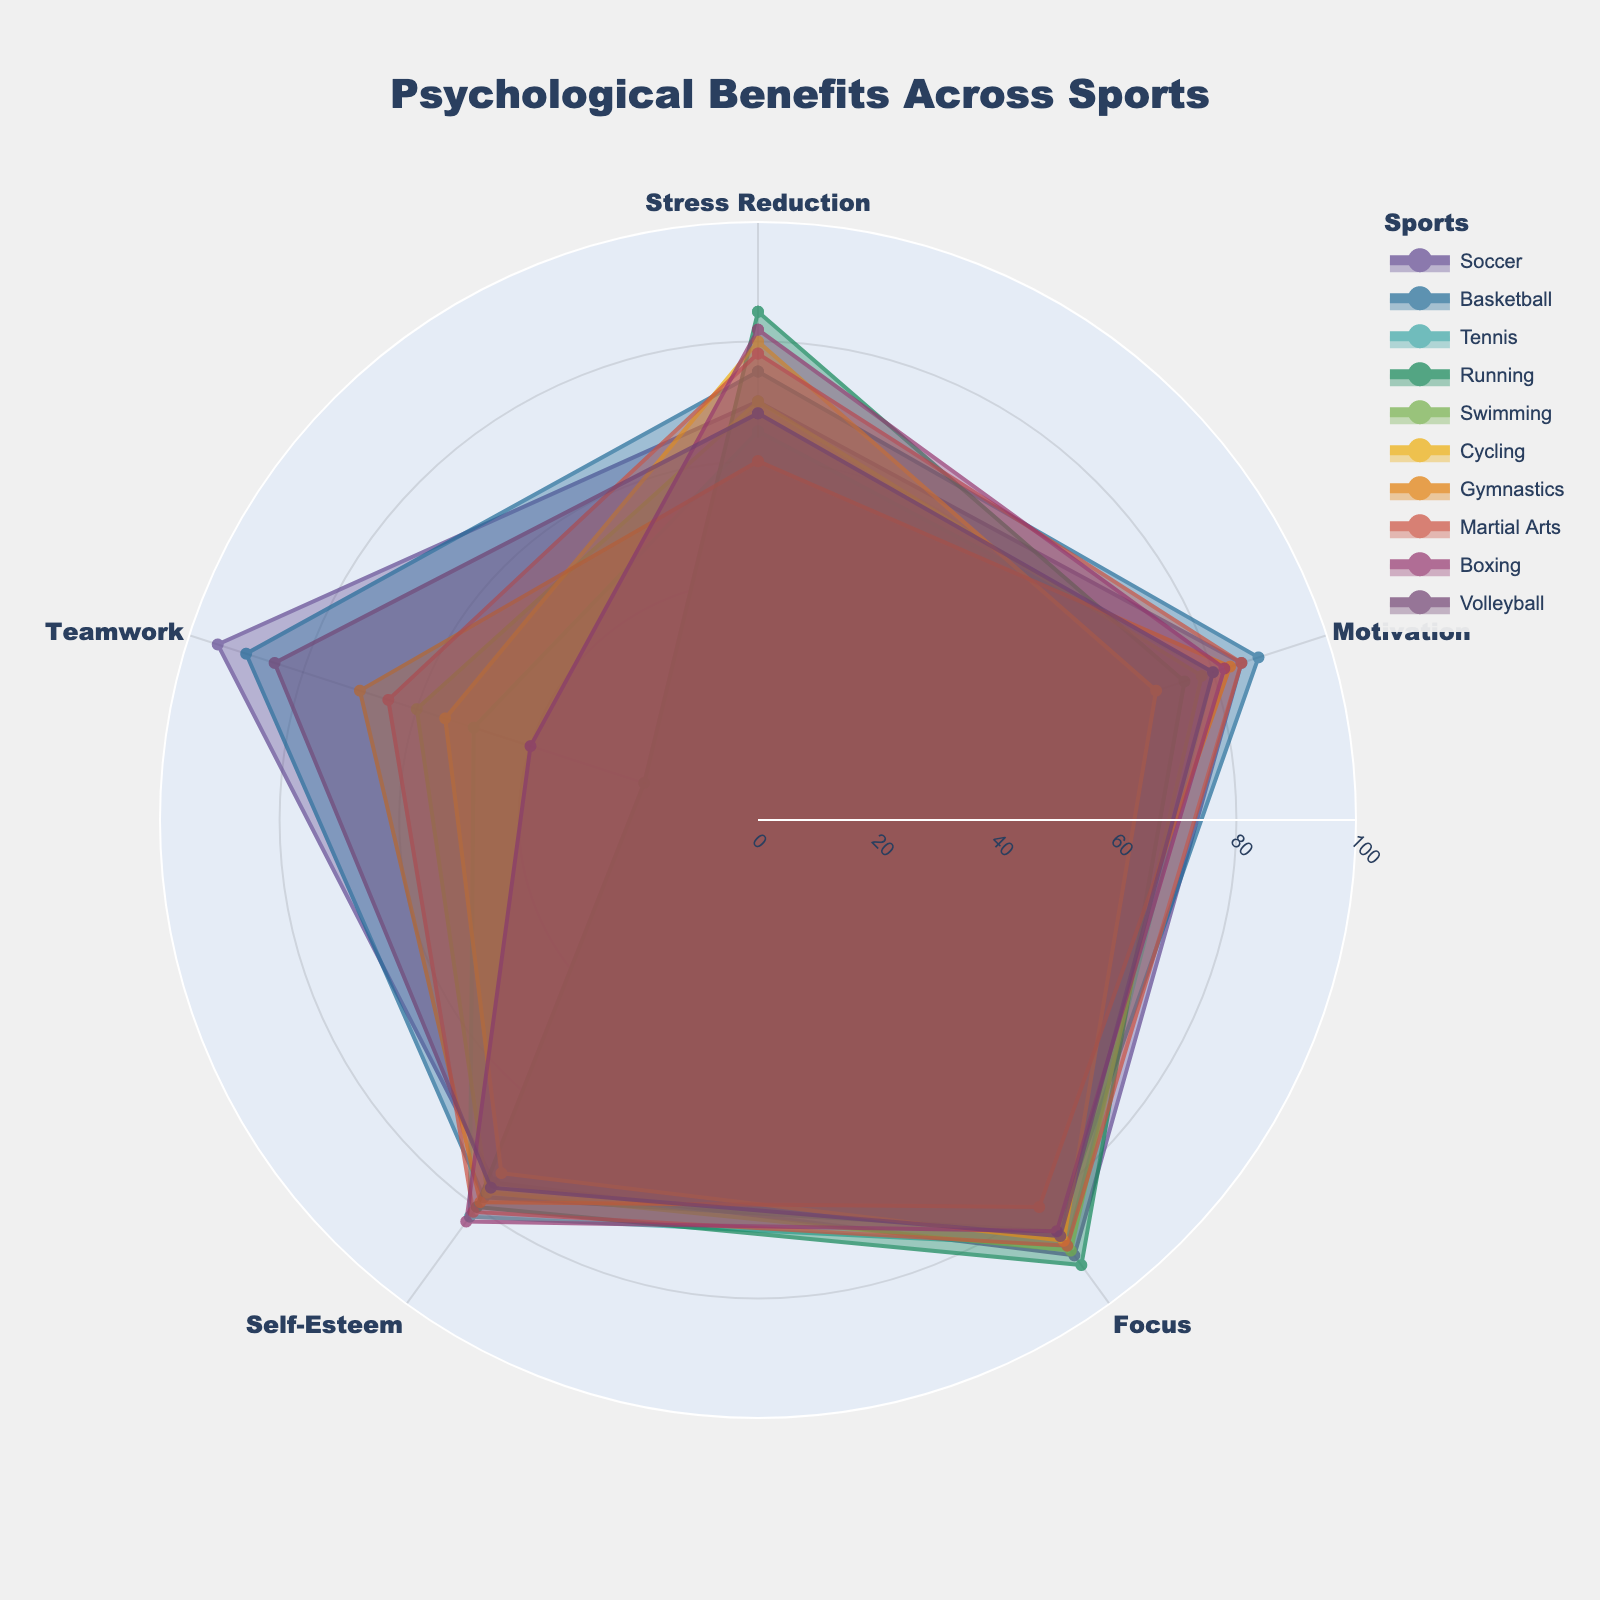What is the title of the figure? The title is typically at the top of the figure and often set in a larger font compared to other text within the chart. By looking at the top, it's clear that the title summarizes the content of the figure.
Answer: Psychological Benefits Across Sports How many different sports are represented in the chart? By examining the legend, which lists each sport with a corresponding color, we can count the number of different sports represented.
Answer: 10 Which sport shows the highest value for teamwork? Find the values for teamwork in each sport’s data, and locate the highest. Soccer shows the highest value.
Answer: Soccer Which two sports show the most similar psychological benefits across all categories? Compare the polygon shapes and radials of different sports to identify which pairs appear the most similar in terms of size and shape. Basketball and Soccer are closely aligned.
Answer: Basketball and Soccer In terms of stress reduction, which sport has the lowest value? By looking at the 'Stress Reduction' radial for each sport, Tennis has the lowest value.
Answer: Tennis What is the average focus score across all sports? Sum up focus scores for all sports (90, 85, 88, 92, 89, 87, 80, 88, 85, 86) and divide by the number of sports (10). The calculation is (90+85+88+92+89+87+80+88+85+86)/10 = 87.
Answer: 87 Which sport shows a significant imbalance between high scores in focus and low scores in teamwork? Find sports with high values in 'Focus' and notably low values in 'Teamwork'. Running shows a high Focus score of 92 and notably low Teamwork score of 20.
Answer: Running Considering both motivation and self-esteem, which sport has the highest combined value? Add the values of motivation and self-esteem for each sport and identify the one with the highest sum. Soccer has the highest combined value (85 + 75 = 160).
Answer: Soccer How does the range of self-esteem values compare to the range of teamwork values? Determine the range (max - min) for both self-esteem and teamwork values. For self-esteem: The range is (83 - 73 = 10). For teamwork: The range is (95 - 20 = 75). Compare both ranges.
Answer: Self-esteem: 10, Teamwork: 75 Which sport offers the highest level of stress reduction? Examine the 'Stress Reduction' values for each sport, and identify the highest one. Running has the highest value.
Answer: Running 